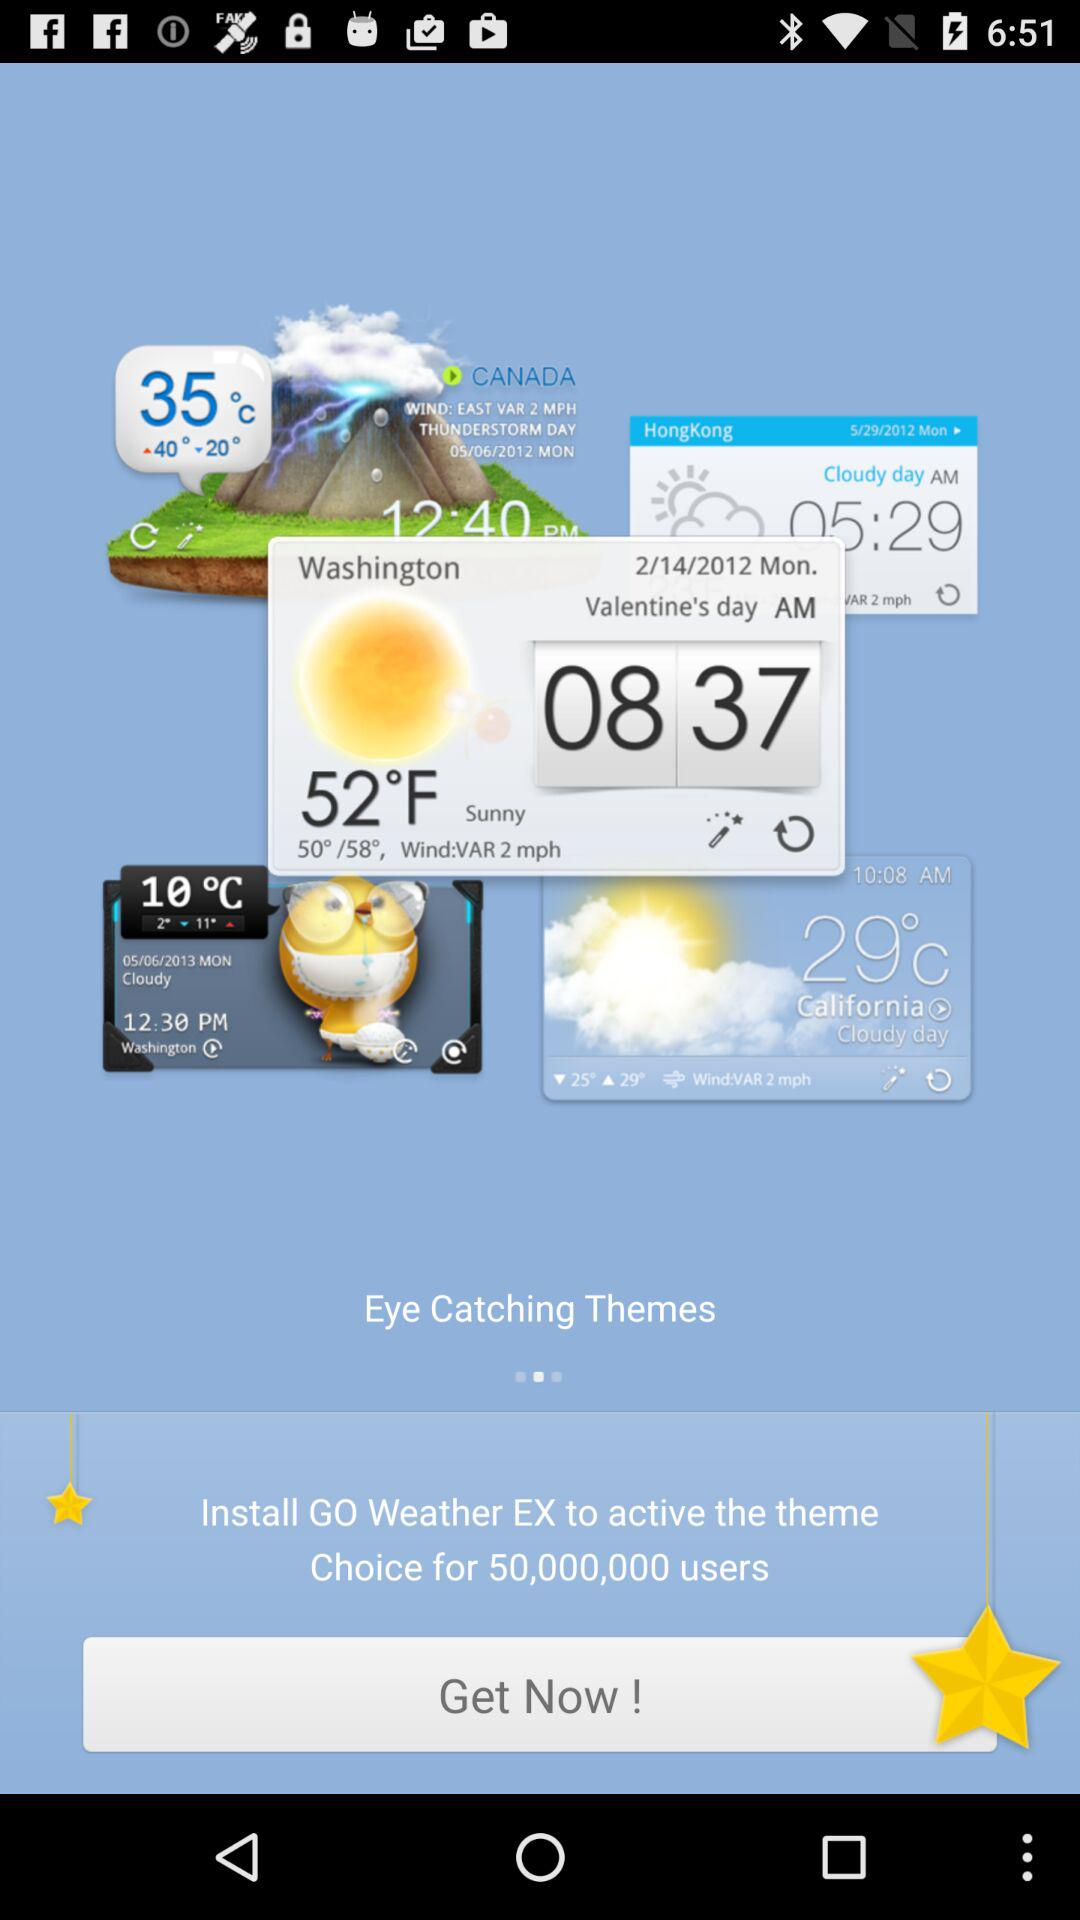What is the temperature on 2/14/2021 as shown on the screen? The temperature is 52°F. 